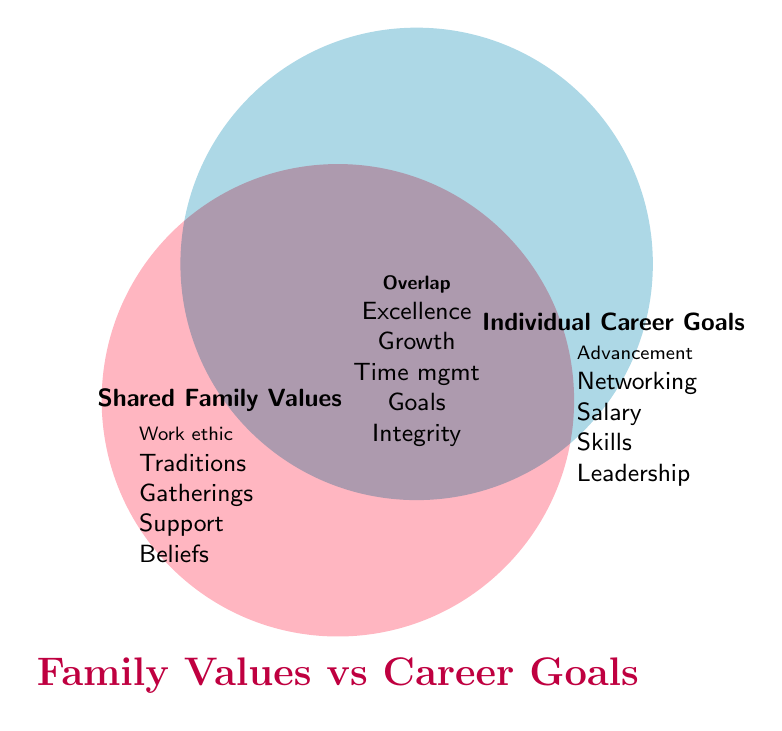What family value indicates mutual support? The "Shared Family Values" section lists mutual support as one of its components.
Answer: Mutual support Which individual career goal aligns with professional networking? The "Individual Career Goals" section lists professional networking as one of its components.
Answer: Professional networking What value is shared between family traditions and professional networking? The "Overlap" section indicates "Personal growth" as a shared value between family traditions and professional networking since it covers elements contributing to both contexts.
Answer: Personal growth Name three values that are part of the overlap between family values and career goals. The "Overlap" section lists values shared between family values and career goals. These include Excellence, Growth, and Time management.
Answer: Excellence, Growth, Time management Which specific family value relates to cultural heritage? The "Shared Family Values" section lists cultural heritage as one of its components.
Answer: Cultural heritage Based on the diagram, which individual career goals pertain to the skill development aspect? The "Individual Career Goals" section lists skill development as one of its components.
Answer: Skill development Compare the number of values listed under family values to those under career goals. Which side has more values? The "Shared Family Values" section lists 6 values, whereas the "Individual Career Goals" section lists 5 values. Therefore, the family values side has more values.
Answer: Family values Which shared value between family values and career goals corresponds to religious beliefs? The "Overlap" section lists shared values, and one should be interpreted to align with religious beliefs, which is integrity in this case.
Answer: Integrity What is the common value related to skill development and goal setting? The "Overlap" section lists shared values, one of which corresponds to both skill development and goal setting.
Answer: Goal setting 